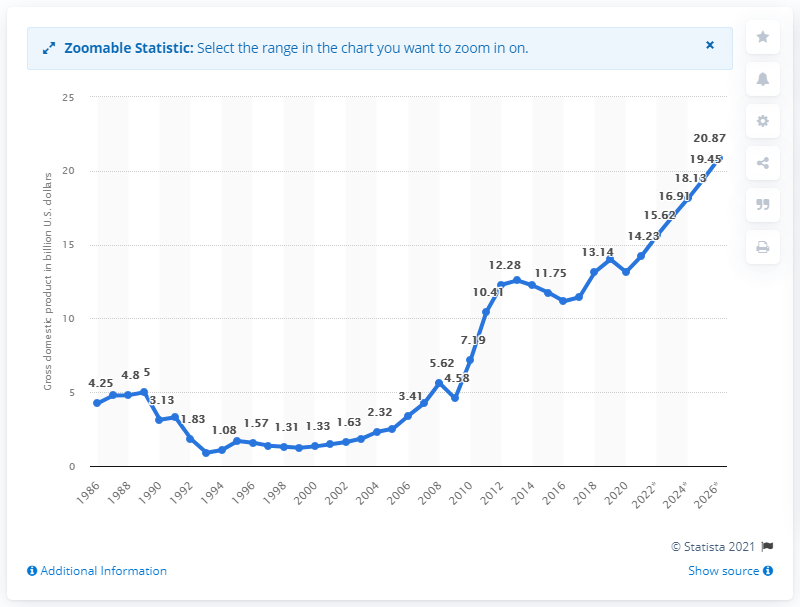Mention a couple of crucial points in this snapshot. In 2020, Mongolia's gross domestic product (GDP) was 13.14 billion dollars. 